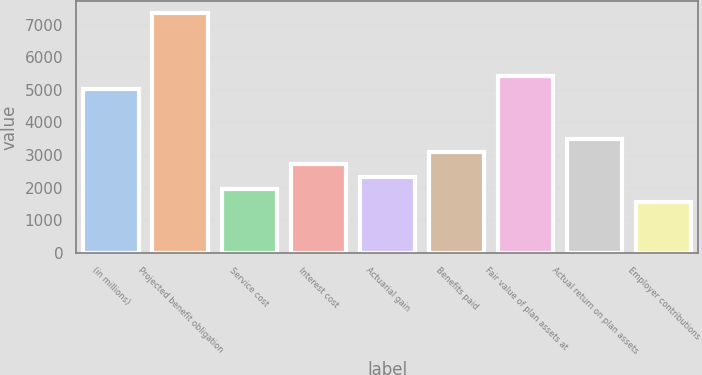Convert chart to OTSL. <chart><loc_0><loc_0><loc_500><loc_500><bar_chart><fcel>(in millions)<fcel>Projected benefit obligation<fcel>Service cost<fcel>Interest cost<fcel>Actuarial gain<fcel>Benefits paid<fcel>Fair value of plan assets at<fcel>Actual return on plan assets<fcel>Employer contributions<nl><fcel>5040.27<fcel>7364.73<fcel>1940.99<fcel>2715.81<fcel>2328.4<fcel>3103.22<fcel>5427.68<fcel>3490.63<fcel>1553.58<nl></chart> 